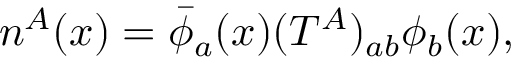Convert formula to latex. <formula><loc_0><loc_0><loc_500><loc_500>n ^ { A } ( x ) = \bar { \phi } _ { a } ( x ) ( T ^ { A } ) _ { a b } \phi _ { b } ( x ) ,</formula> 